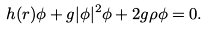Convert formula to latex. <formula><loc_0><loc_0><loc_500><loc_500>h ( { r } ) \phi + g | \phi | ^ { 2 } \phi + 2 g \rho \phi = 0 .</formula> 